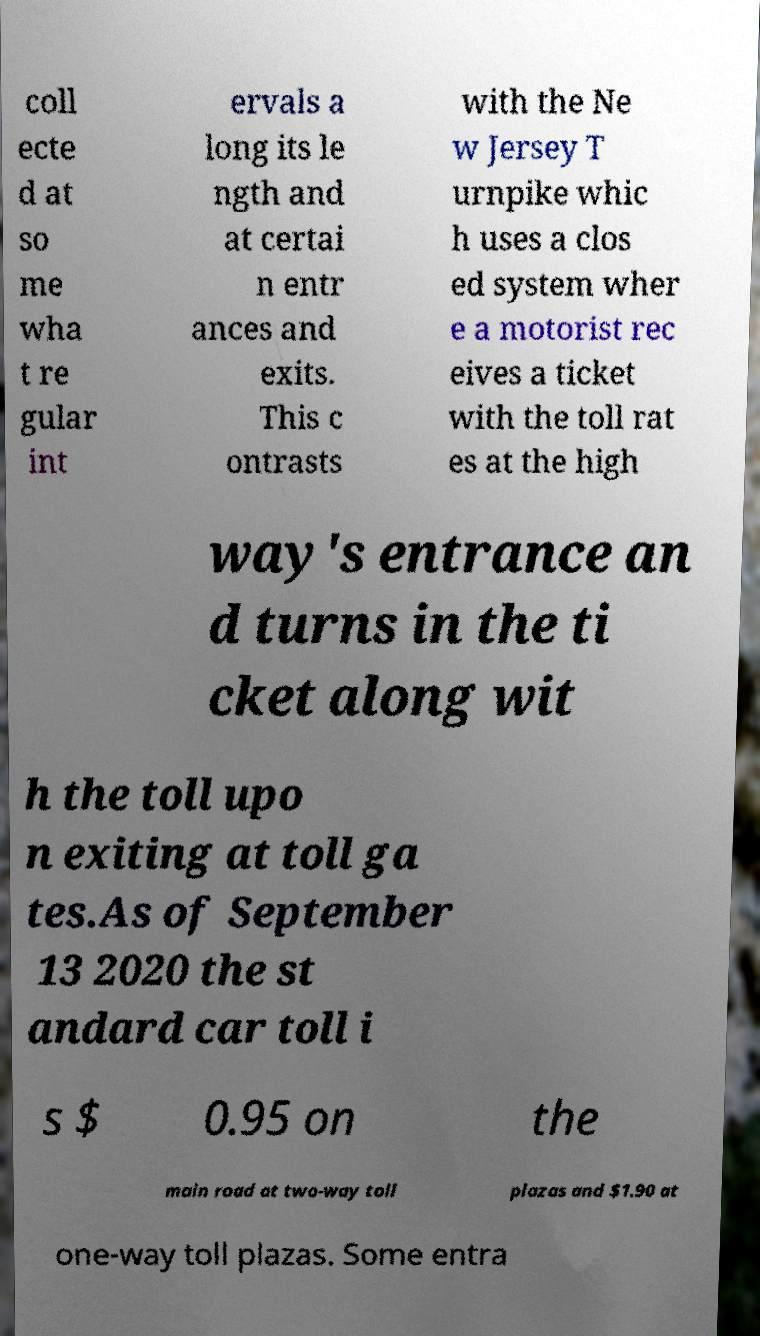For documentation purposes, I need the text within this image transcribed. Could you provide that? coll ecte d at so me wha t re gular int ervals a long its le ngth and at certai n entr ances and exits. This c ontrasts with the Ne w Jersey T urnpike whic h uses a clos ed system wher e a motorist rec eives a ticket with the toll rat es at the high way's entrance an d turns in the ti cket along wit h the toll upo n exiting at toll ga tes.As of September 13 2020 the st andard car toll i s $ 0.95 on the main road at two-way toll plazas and $1.90 at one-way toll plazas. Some entra 